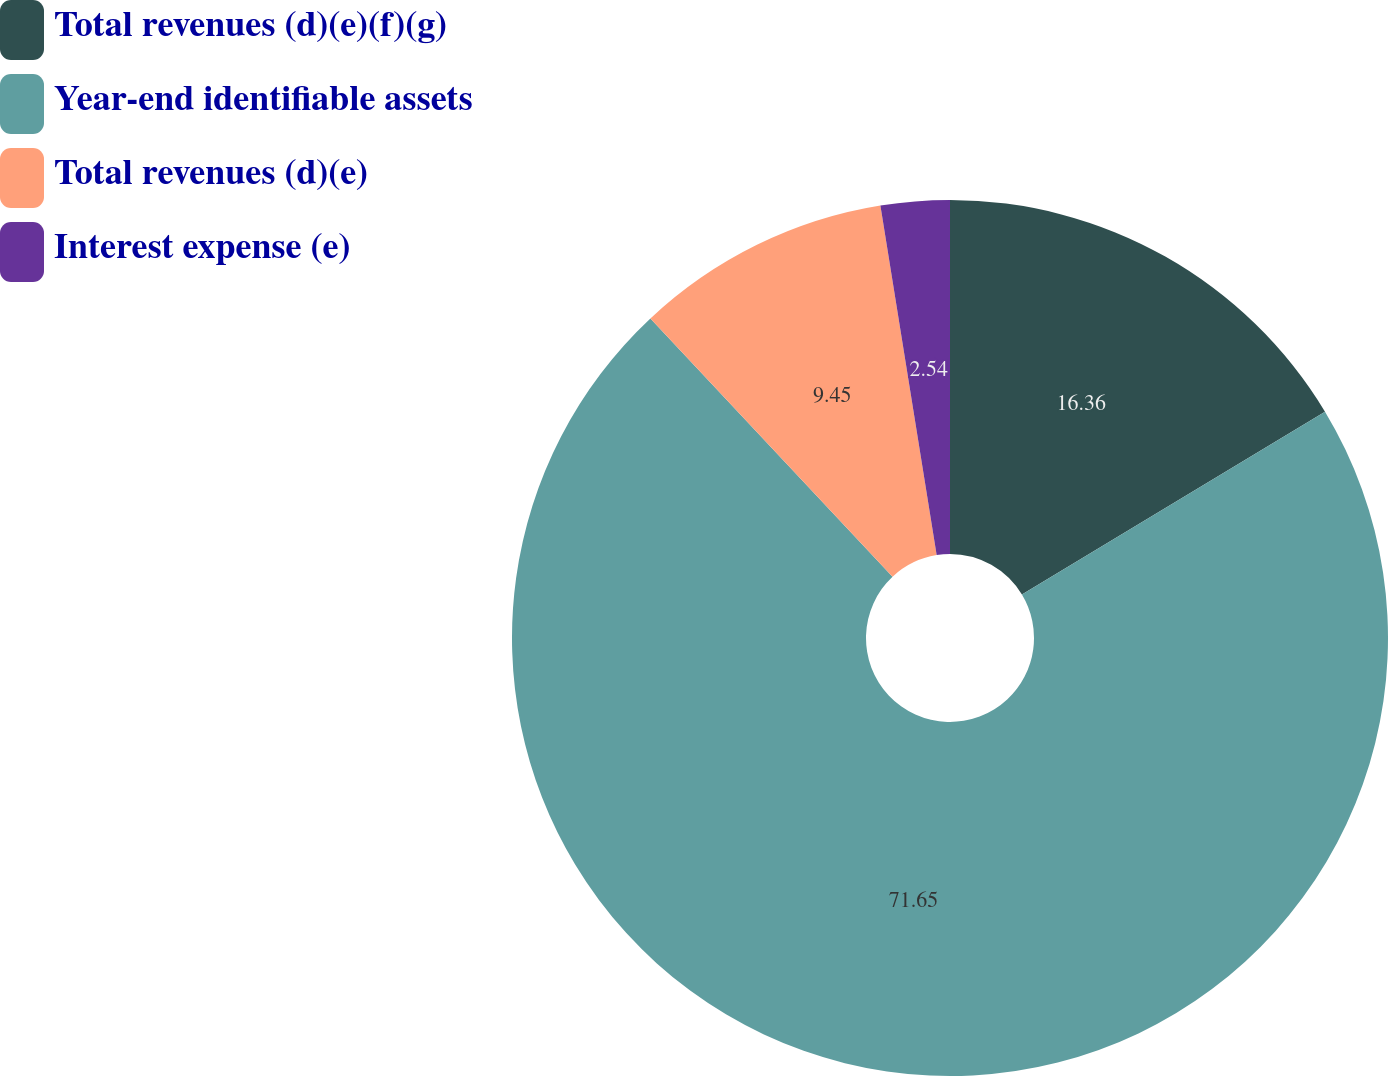Convert chart. <chart><loc_0><loc_0><loc_500><loc_500><pie_chart><fcel>Total revenues (d)(e)(f)(g)<fcel>Year-end identifiable assets<fcel>Total revenues (d)(e)<fcel>Interest expense (e)<nl><fcel>16.36%<fcel>71.66%<fcel>9.45%<fcel>2.54%<nl></chart> 